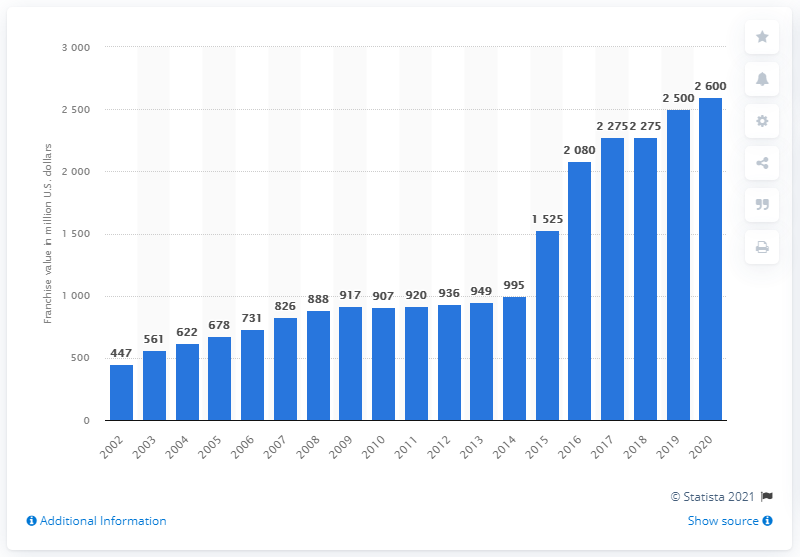Give some essential details in this illustration. In 2020, the franchise value of the Los Angeles Chargers was 2,600. 